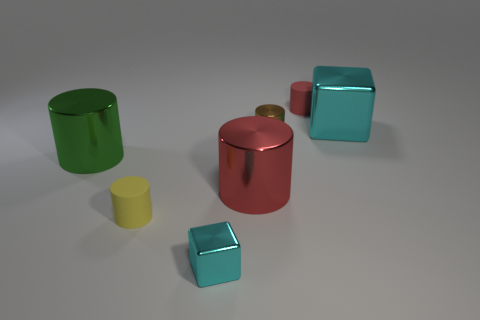What number of matte objects are either tiny red objects or brown cylinders?
Give a very brief answer. 1. How big is the rubber cylinder that is to the left of the tiny metallic cylinder?
Ensure brevity in your answer.  Small. Is the shape of the big red object the same as the tiny yellow matte thing?
Make the answer very short. Yes. What number of small objects are either red cylinders or green things?
Give a very brief answer. 1. There is a large cyan metallic object; are there any objects behind it?
Your answer should be compact. Yes. Are there an equal number of brown metallic objects that are in front of the big green metal cylinder and green cubes?
Ensure brevity in your answer.  Yes. What size is the red rubber thing that is the same shape as the green object?
Offer a terse response. Small. Do the tiny yellow rubber object and the big metallic thing behind the green cylinder have the same shape?
Provide a short and direct response. No. How big is the matte thing that is on the left side of the cyan object in front of the large red cylinder?
Offer a terse response. Small. Are there the same number of red things in front of the big green cylinder and red cylinders behind the big red metallic thing?
Ensure brevity in your answer.  Yes. 